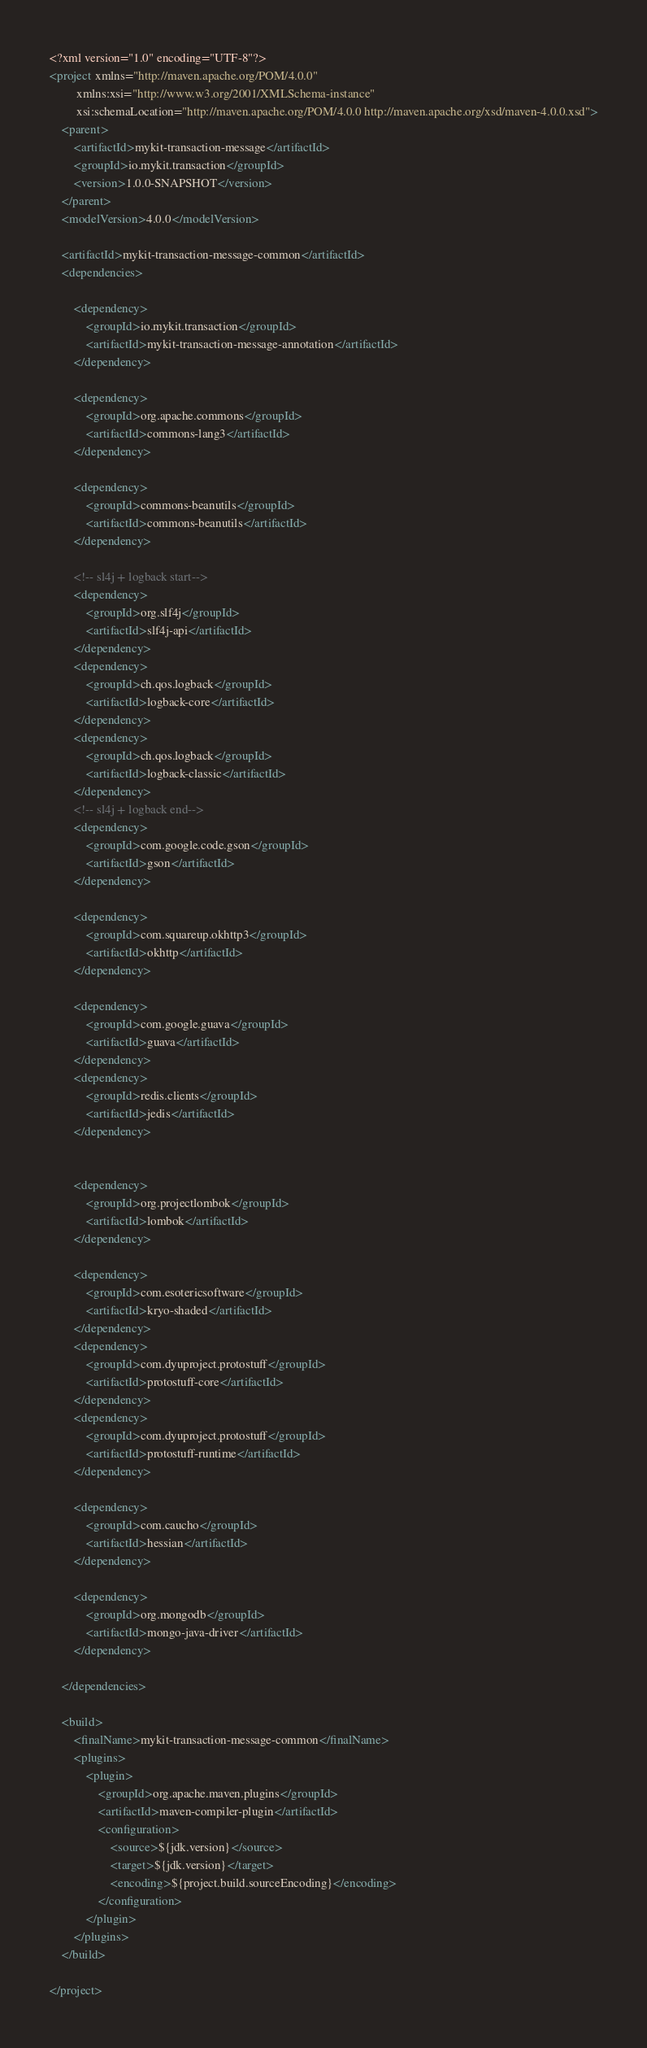Convert code to text. <code><loc_0><loc_0><loc_500><loc_500><_XML_><?xml version="1.0" encoding="UTF-8"?>
<project xmlns="http://maven.apache.org/POM/4.0.0"
         xmlns:xsi="http://www.w3.org/2001/XMLSchema-instance"
         xsi:schemaLocation="http://maven.apache.org/POM/4.0.0 http://maven.apache.org/xsd/maven-4.0.0.xsd">
    <parent>
        <artifactId>mykit-transaction-message</artifactId>
        <groupId>io.mykit.transaction</groupId>
        <version>1.0.0-SNAPSHOT</version>
    </parent>
    <modelVersion>4.0.0</modelVersion>

    <artifactId>mykit-transaction-message-common</artifactId>
    <dependencies>

        <dependency>
            <groupId>io.mykit.transaction</groupId>
            <artifactId>mykit-transaction-message-annotation</artifactId>
        </dependency>

        <dependency>
            <groupId>org.apache.commons</groupId>
            <artifactId>commons-lang3</artifactId>
        </dependency>

        <dependency>
            <groupId>commons-beanutils</groupId>
            <artifactId>commons-beanutils</artifactId>
        </dependency>

        <!-- sl4j + logback start-->
        <dependency>
            <groupId>org.slf4j</groupId>
            <artifactId>slf4j-api</artifactId>
        </dependency>
        <dependency>
            <groupId>ch.qos.logback</groupId>
            <artifactId>logback-core</artifactId>
        </dependency>
        <dependency>
            <groupId>ch.qos.logback</groupId>
            <artifactId>logback-classic</artifactId>
        </dependency>
        <!-- sl4j + logback end-->
        <dependency>
            <groupId>com.google.code.gson</groupId>
            <artifactId>gson</artifactId>
        </dependency>

        <dependency>
            <groupId>com.squareup.okhttp3</groupId>
            <artifactId>okhttp</artifactId>
        </dependency>

        <dependency>
            <groupId>com.google.guava</groupId>
            <artifactId>guava</artifactId>
        </dependency>
        <dependency>
            <groupId>redis.clients</groupId>
            <artifactId>jedis</artifactId>
        </dependency>


        <dependency>
            <groupId>org.projectlombok</groupId>
            <artifactId>lombok</artifactId>
        </dependency>

        <dependency>
            <groupId>com.esotericsoftware</groupId>
            <artifactId>kryo-shaded</artifactId>
        </dependency>
        <dependency>
            <groupId>com.dyuproject.protostuff</groupId>
            <artifactId>protostuff-core</artifactId>
        </dependency>
        <dependency>
            <groupId>com.dyuproject.protostuff</groupId>
            <artifactId>protostuff-runtime</artifactId>
        </dependency>

        <dependency>
            <groupId>com.caucho</groupId>
            <artifactId>hessian</artifactId>
        </dependency>

        <dependency>
            <groupId>org.mongodb</groupId>
            <artifactId>mongo-java-driver</artifactId>
        </dependency>

    </dependencies>

    <build>
        <finalName>mykit-transaction-message-common</finalName>
        <plugins>
            <plugin>
                <groupId>org.apache.maven.plugins</groupId>
                <artifactId>maven-compiler-plugin</artifactId>
                <configuration>
                    <source>${jdk.version}</source>
                    <target>${jdk.version}</target>
                    <encoding>${project.build.sourceEncoding}</encoding>
                </configuration>
            </plugin>
        </plugins>
    </build>

</project></code> 